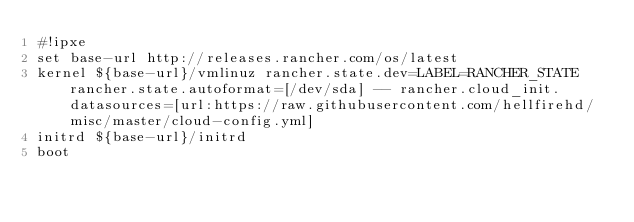<code> <loc_0><loc_0><loc_500><loc_500><_Clojure_>#!ipxe
set base-url http://releases.rancher.com/os/latest
kernel ${base-url}/vmlinuz rancher.state.dev=LABEL=RANCHER_STATE rancher.state.autoformat=[/dev/sda] -- rancher.cloud_init.datasources=[url:https://raw.githubusercontent.com/hellfirehd/misc/master/cloud-config.yml]
initrd ${base-url}/initrd
boot
</code> 